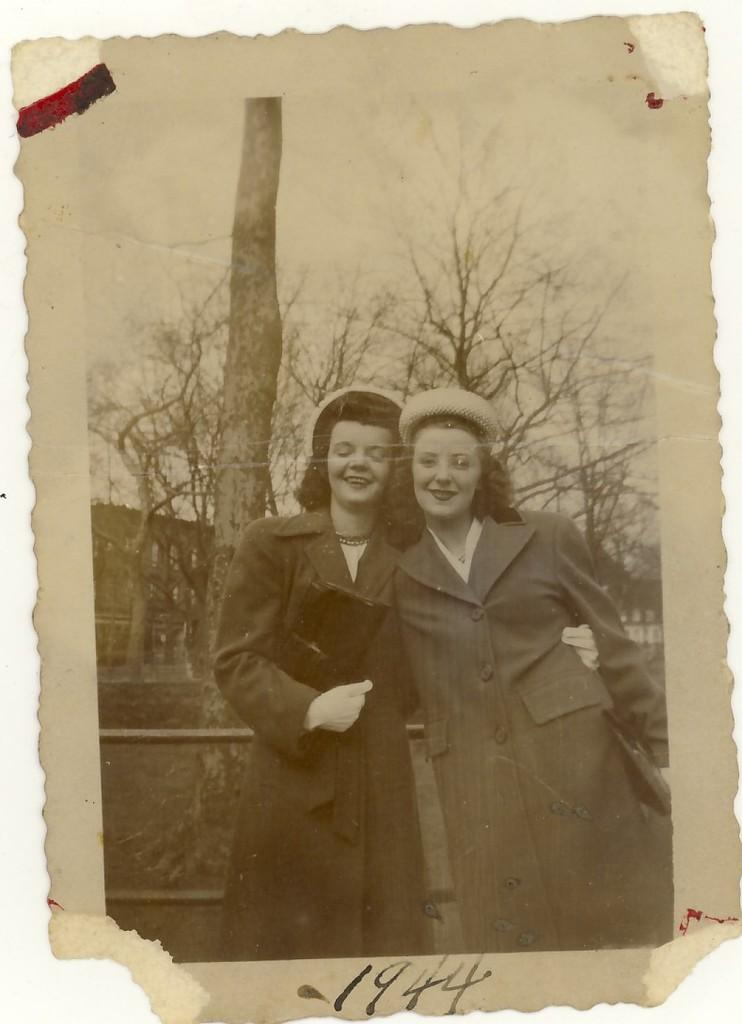What is the color scheme of the image? The image is black and white. How many people are in the image? There are two women in the image. What is the facial expression of the women? The women are smiling. What are the women doing in the image? The women are posing for a photograph. What can be seen in the background of the image? There are trees in the background of the image. What type of card is the woman holding in the image? There is no card visible in the image; the women are posing for a photograph without any visible objects in their hands. 